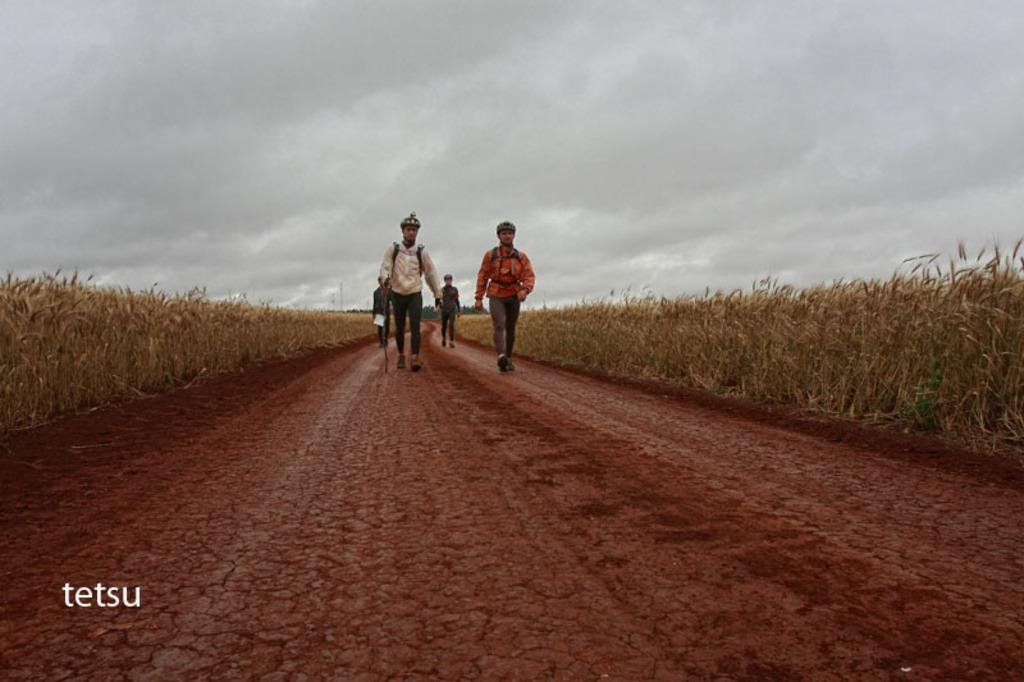In one or two sentences, can you explain what this image depicts? In this image, we can see some persons walking at the middle, at the right and left sides we can see some dried weeds, at the top there is a sky which is cloudy. 